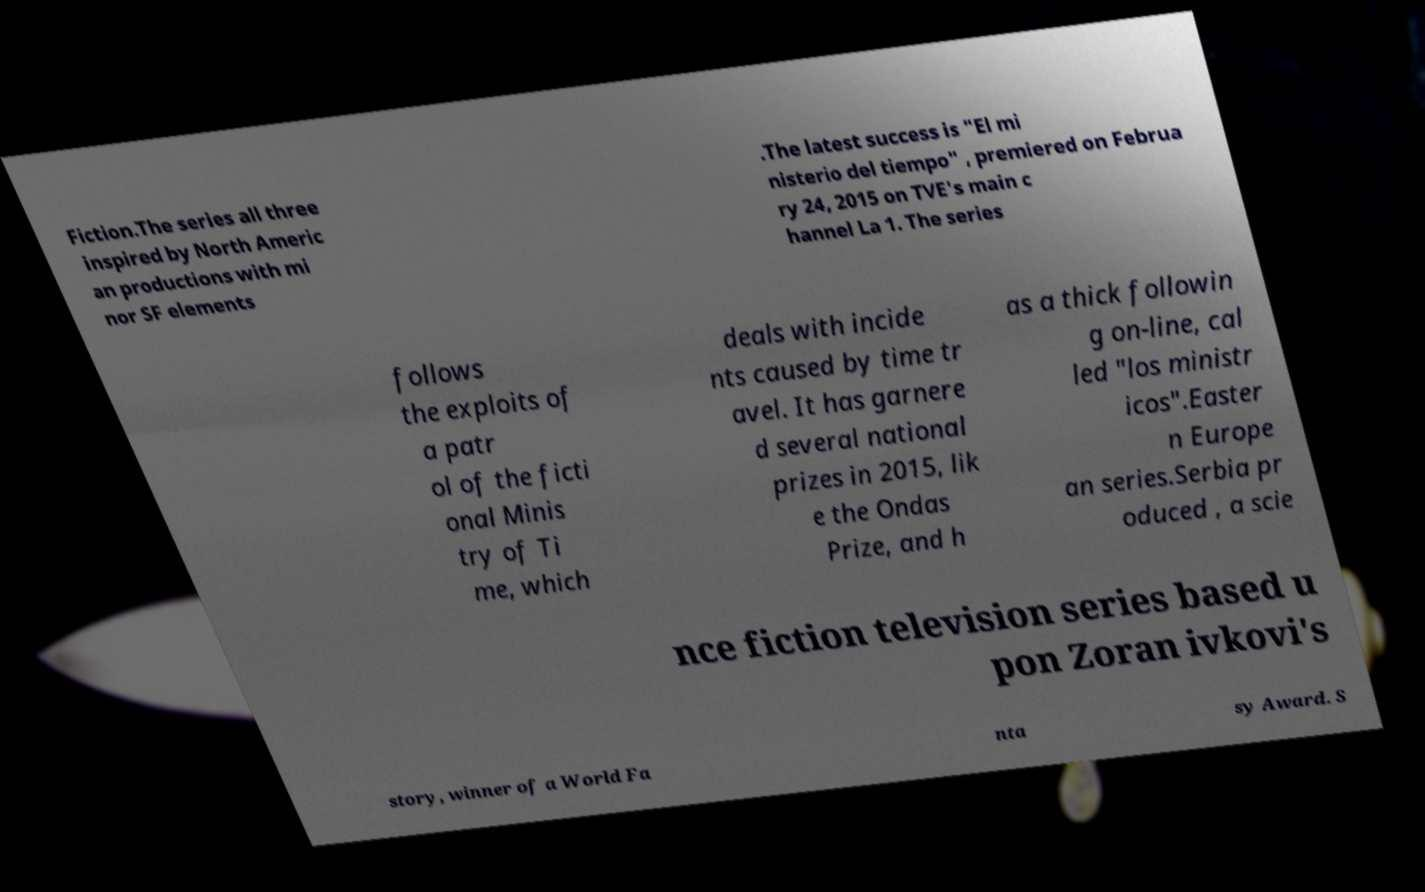There's text embedded in this image that I need extracted. Can you transcribe it verbatim? Fiction.The series all three inspired by North Americ an productions with mi nor SF elements .The latest success is "El mi nisterio del tiempo" , premiered on Februa ry 24, 2015 on TVE's main c hannel La 1. The series follows the exploits of a patr ol of the ficti onal Minis try of Ti me, which deals with incide nts caused by time tr avel. It has garnere d several national prizes in 2015, lik e the Ondas Prize, and h as a thick followin g on-line, cal led "los ministr icos".Easter n Europe an series.Serbia pr oduced , a scie nce fiction television series based u pon Zoran ivkovi's story, winner of a World Fa nta sy Award. S 